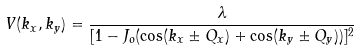<formula> <loc_0><loc_0><loc_500><loc_500>V ( k _ { x } , k _ { y } ) = \frac { \lambda } { [ 1 - J _ { o } ( \cos ( k _ { x } \pm Q _ { x } ) + \cos ( k _ { y } \pm Q _ { y } ) ) ] ^ { 2 } }</formula> 